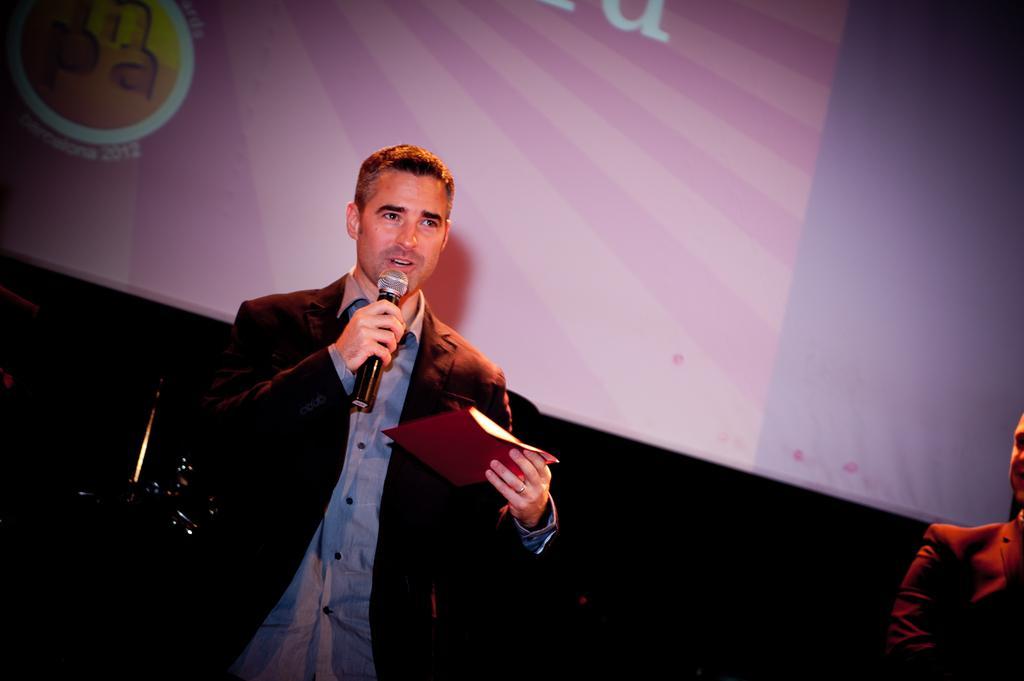Describe this image in one or two sentences. In this picture I can see a man is holding a microphone and an object in the hands. In the background I can see a projector screen. On the right side I can see a person. 